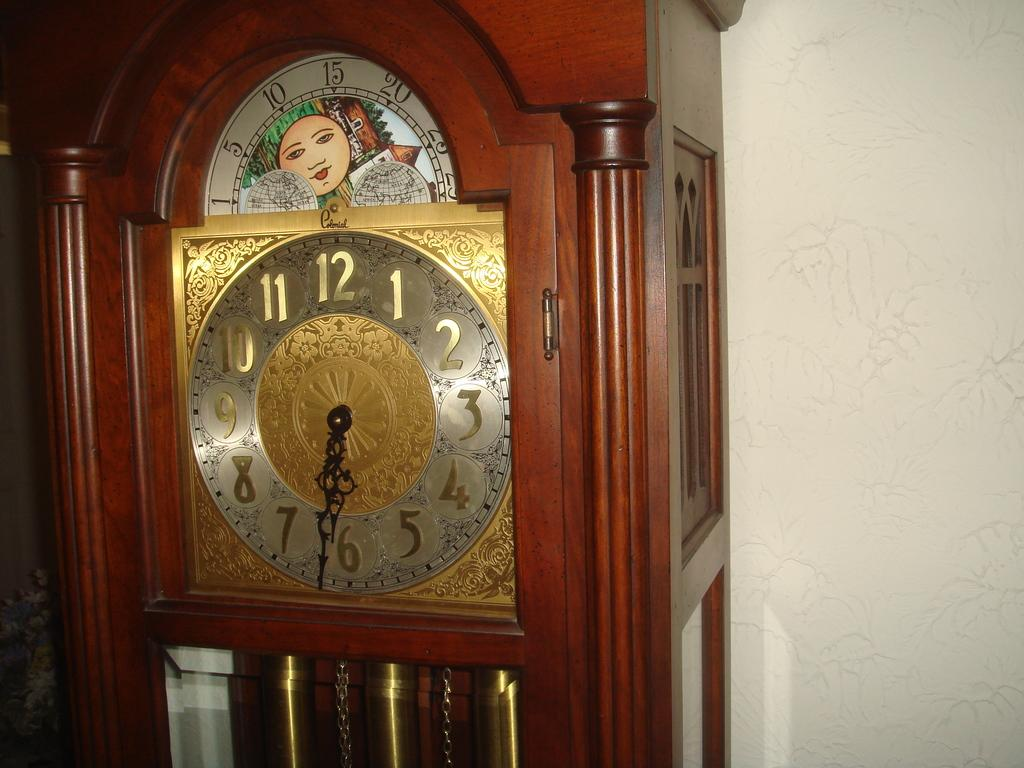<image>
Share a concise interpretation of the image provided. A grandfather clock that has the work Colonial written in cursive near the top. 